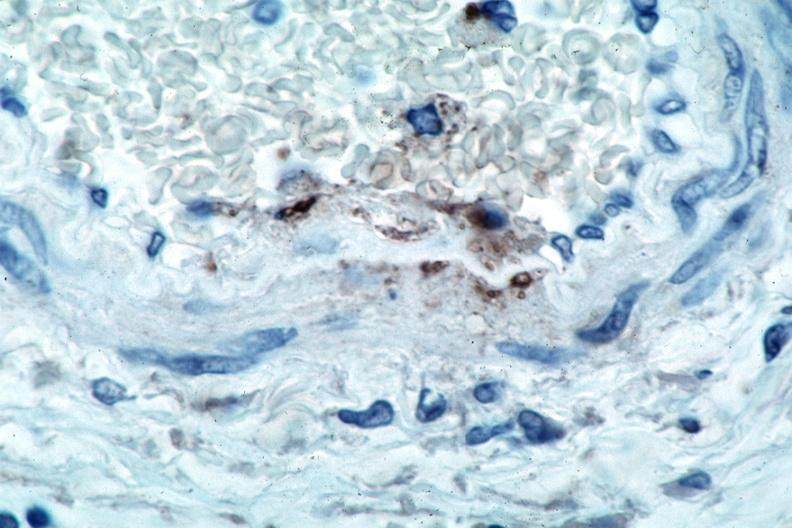s rocky mountain spotted fever, immunoperoxidase staining vessels for rickettsia rickettsii?
Answer the question using a single word or phrase. Yes 